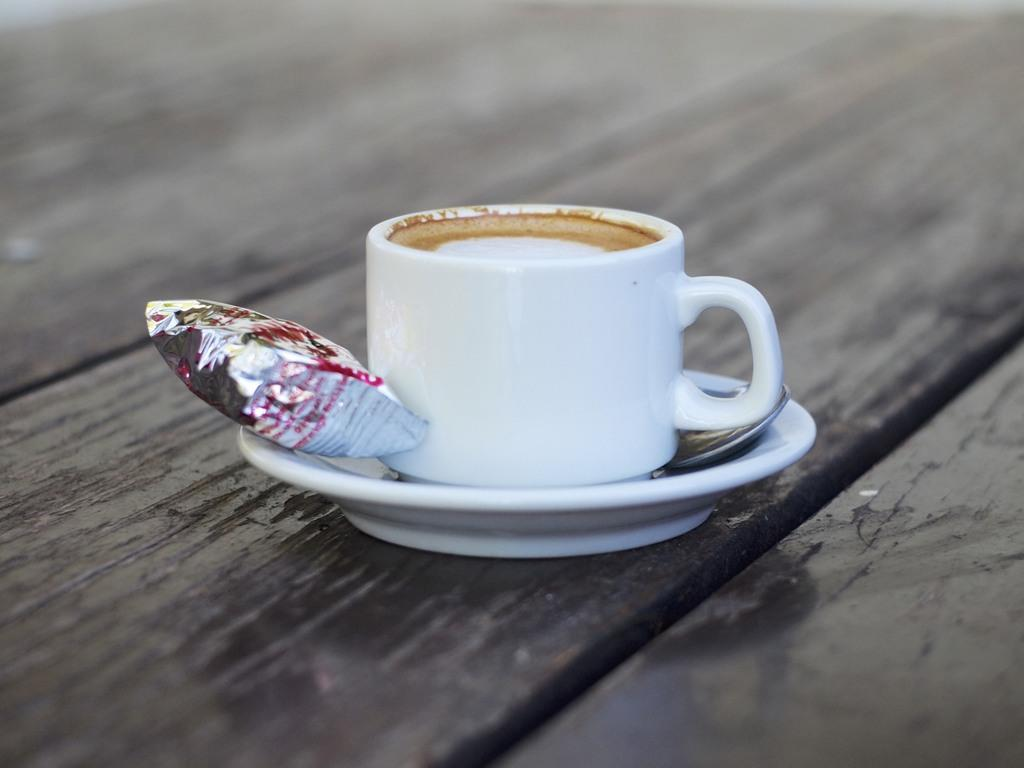What is present in the image that can be used for drinking? There is a cup in the image that can be used for drinking. What is another item in the image that is related to the cup? There is a spoon in the image that can be used with the cup. What is in the saucer that accompanies the cup? There is a packet in the saucer. What is inside the cup? There is a drink in the cup. Where is the sheep grazing in the image? There is no sheep present in the image. Can you describe the friend sitting next to the person in the image? There is no friend or person present in the image. 